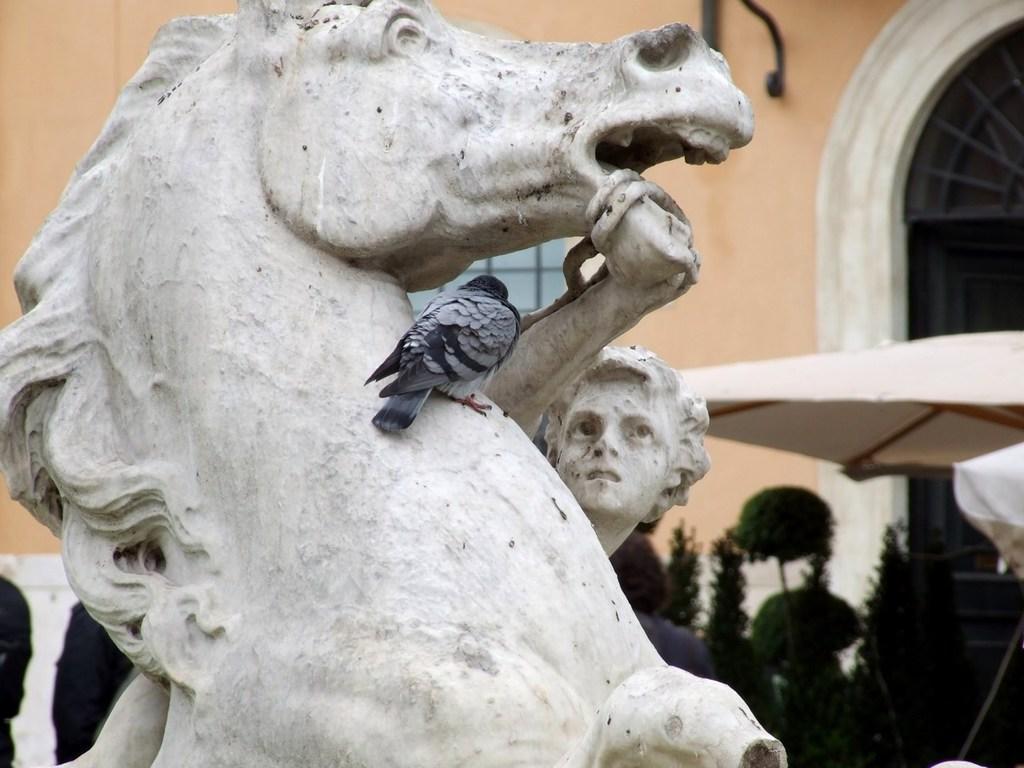Can you describe this image briefly? In this image we can see a bird on a statue. On the backside we can see a building with windows, a roof and some plants. We can also see a person. 